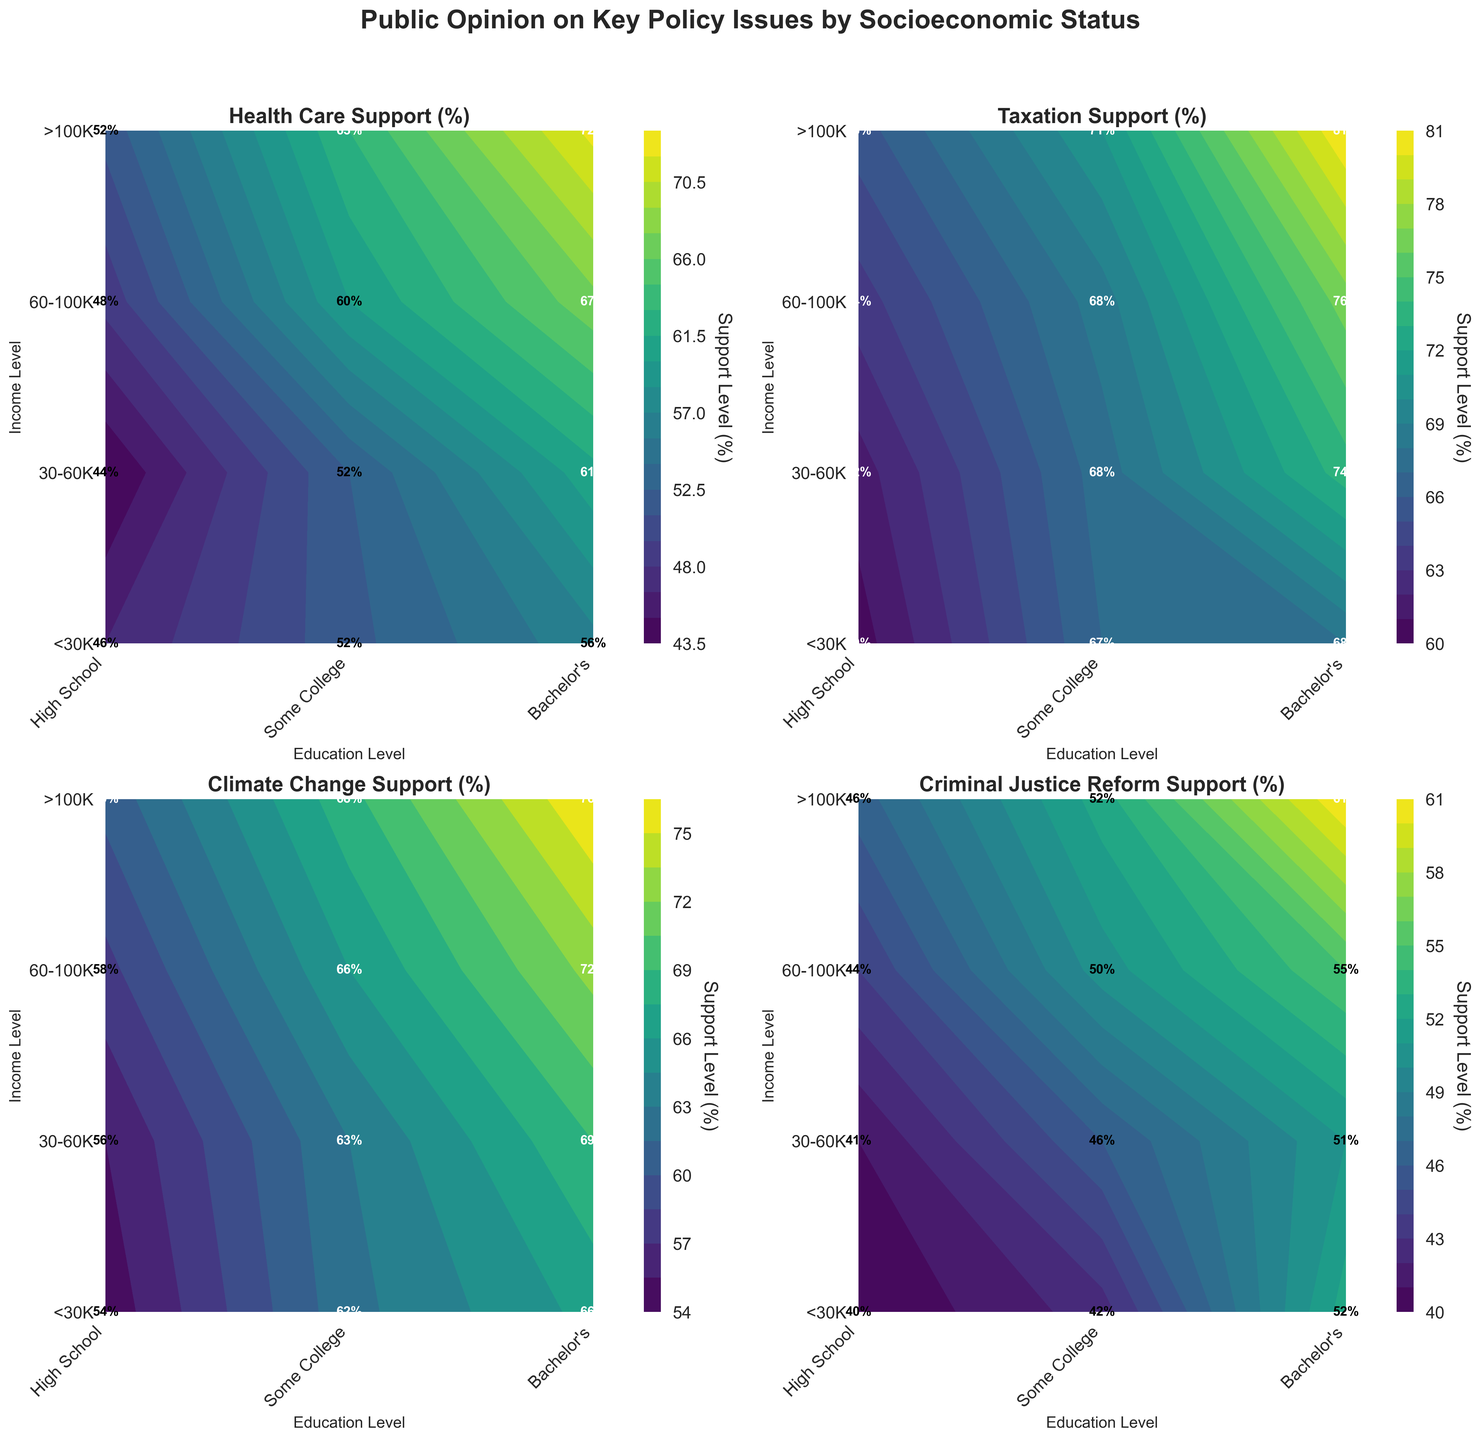What is the title of the entire figure? The title is displayed at the top of the figure.
Answer: Public Opinion on Key Policy Issues by Socioeconomic Status What are the axes labels for the subplot on Climate Change Support? The subplot shows the axes labels on the bottom and left sides.
Answer: Education Level and Income Level Which policy support has the highest value in the >100K income level and Bachelor's education level? Look for the highest value in the contours for the >100K income level and Bachelor's education level across all subplots.
Answer: Climate Change Support with 78% How does the support for Health Care change with income for those with a Bachelor's degree? Compare the contour levels for different income levels under the Bachelor's category in the Health Care Support subplot.
Answer: It increases from 60% at <30K to 70% at 60-100K, and 75% at >100K Which education level shows the most support for Criminal Justice Reform in the <30K income group? Check the contour plot for Criminal Justice Reform Support under the <30K income group and compare the values for different education levels.
Answer: Bachelor's Is the support for Taxation generally higher for those with some college education or high school education? Compare the contour plots for Taxation Support at both education levels across all income groups.
Answer: Some College What is the range of support values (minimum to maximum) for Climate Change across all socioeconomic statuses? Identify the minimum and maximum values in the Climate Change Support subplot.
Answer: 54% to 78% How does support for Health Care among individuals earning 30-60K with some college education compare to those earning 60-100K with high school education? Compare the contour levels at the intersections of these specific income and education levels in the Health Care Support subplot.
Answer: 55% for 30-60K with some college vs. 50% for 60-100K with high school Which subgroup shows the least support for Taxation? Look for the lowest contour value in the Taxation Support subplot.
Answer: 60-100K income and Rural High School with 60% Does higher education consistently correlate with higher support for Health Care across all income groups? Observe the trend in contour levels in the Health Care Support subplot as education level increases within each income group.
Answer: Yes 